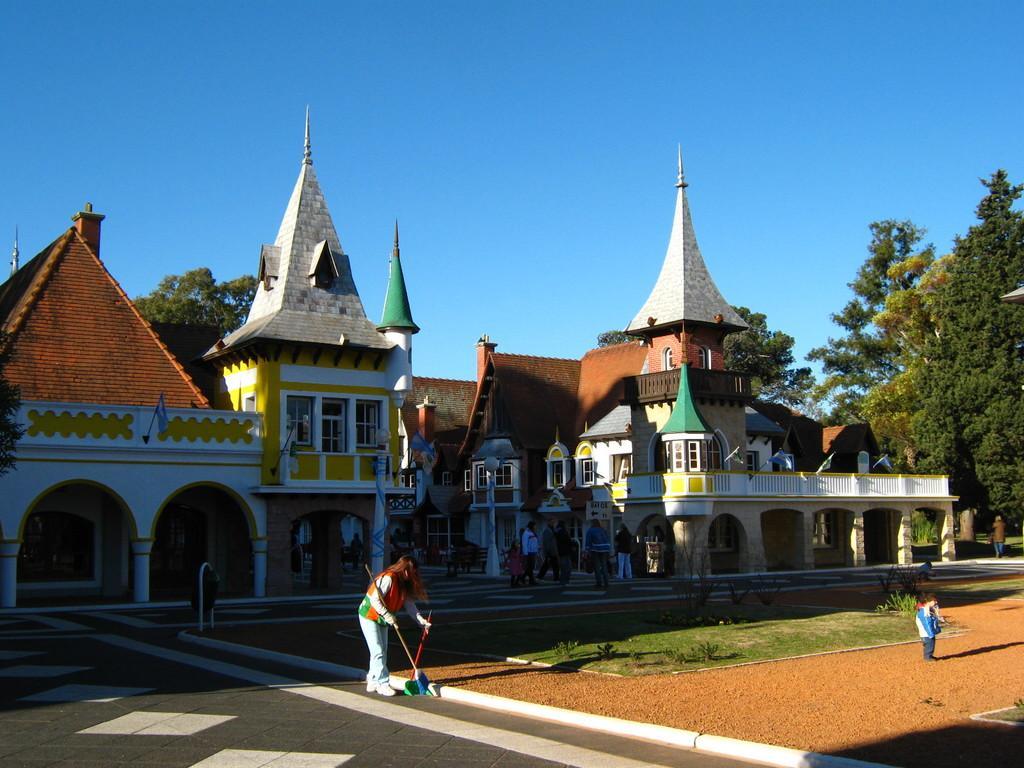Describe this image in one or two sentences. In this picture there are buildings and trees. In the foreground there are is a woman standing and holding the objects and there is a boy standing. At the back there are group of people and there are flags on the buildings. At the top there is sky. At the bottom there is a road and there is grass and ground. 